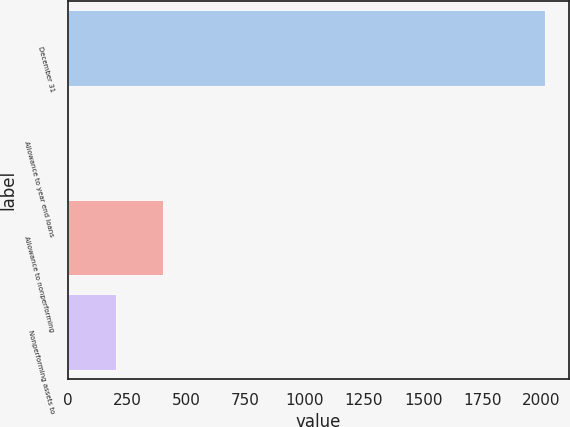Convert chart to OTSL. <chart><loc_0><loc_0><loc_500><loc_500><bar_chart><fcel>December 31<fcel>Allowance to year end loans<fcel>Allowance to nonperforming<fcel>Nonperforming assets to<nl><fcel>2015<fcel>0.21<fcel>403.17<fcel>201.69<nl></chart> 